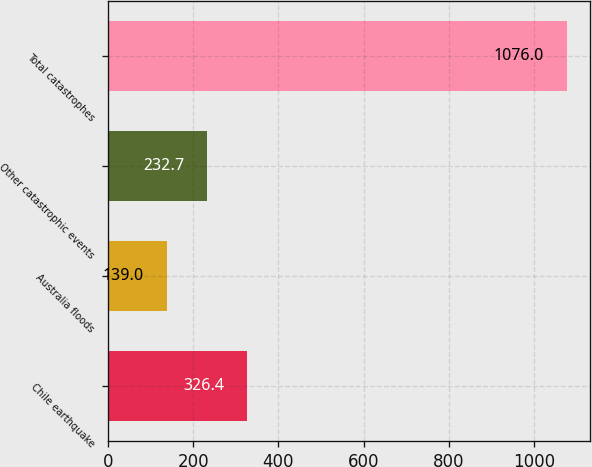Convert chart. <chart><loc_0><loc_0><loc_500><loc_500><bar_chart><fcel>Chile earthquake<fcel>Australia floods<fcel>Other catastrophic events<fcel>Total catastrophes<nl><fcel>326.4<fcel>139<fcel>232.7<fcel>1076<nl></chart> 